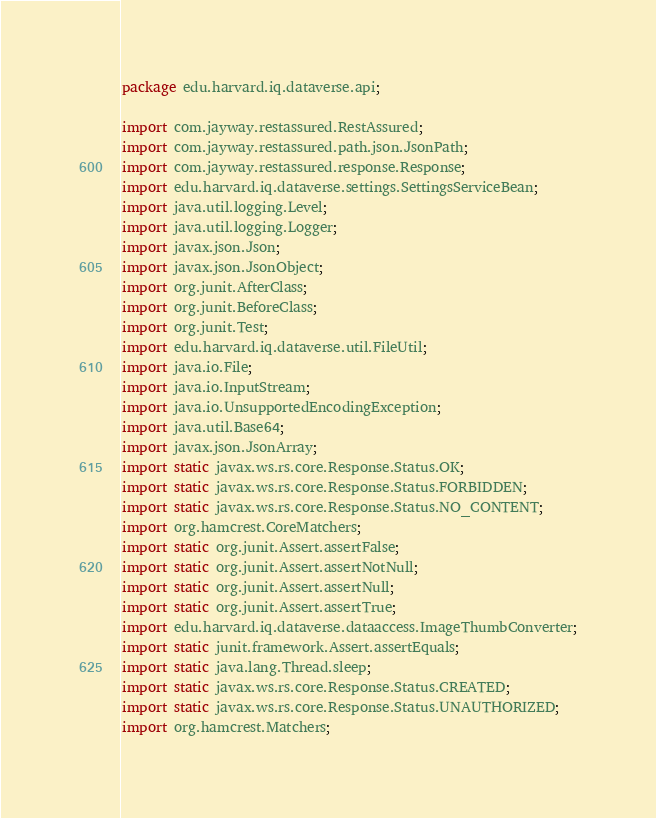Convert code to text. <code><loc_0><loc_0><loc_500><loc_500><_Java_>package edu.harvard.iq.dataverse.api;

import com.jayway.restassured.RestAssured;
import com.jayway.restassured.path.json.JsonPath;
import com.jayway.restassured.response.Response;
import edu.harvard.iq.dataverse.settings.SettingsServiceBean;
import java.util.logging.Level;
import java.util.logging.Logger;
import javax.json.Json;
import javax.json.JsonObject;
import org.junit.AfterClass;
import org.junit.BeforeClass;
import org.junit.Test;
import edu.harvard.iq.dataverse.util.FileUtil;
import java.io.File;
import java.io.InputStream;
import java.io.UnsupportedEncodingException;
import java.util.Base64;
import javax.json.JsonArray;
import static javax.ws.rs.core.Response.Status.OK;
import static javax.ws.rs.core.Response.Status.FORBIDDEN;
import static javax.ws.rs.core.Response.Status.NO_CONTENT;
import org.hamcrest.CoreMatchers;
import static org.junit.Assert.assertFalse;
import static org.junit.Assert.assertNotNull;
import static org.junit.Assert.assertNull;
import static org.junit.Assert.assertTrue;
import edu.harvard.iq.dataverse.dataaccess.ImageThumbConverter;
import static junit.framework.Assert.assertEquals;
import static java.lang.Thread.sleep;
import static javax.ws.rs.core.Response.Status.CREATED;
import static javax.ws.rs.core.Response.Status.UNAUTHORIZED;
import org.hamcrest.Matchers;</code> 